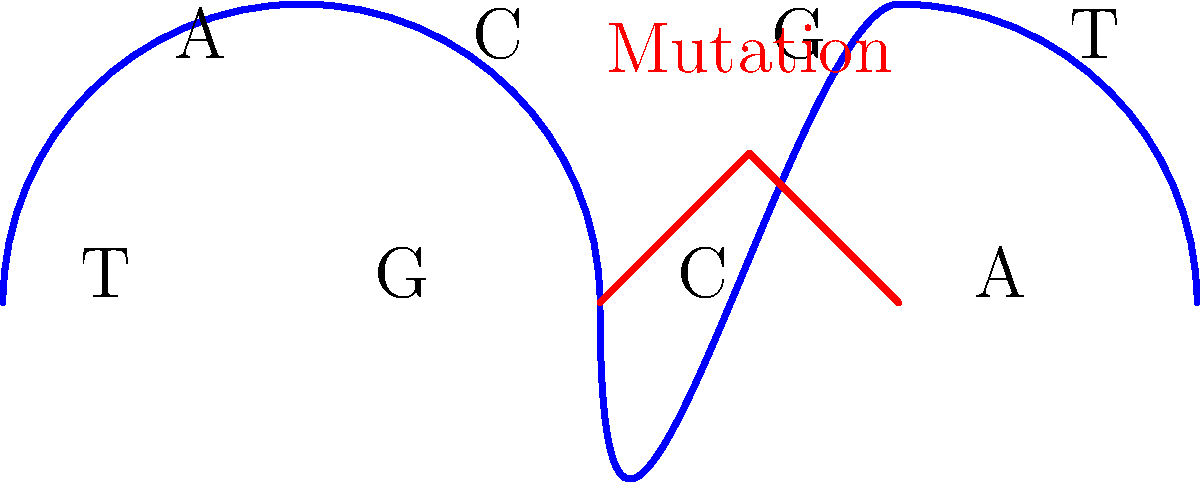In the DNA structure shown above, a genetic mutation has occurred. What type of mutation is represented by the red segment, and how might it affect the genetic information? To understand this mutation, let's break it down step-by-step:

1. DNA structure: The blue curve represents the double helix structure of DNA. Each rung of the "ladder" represents a base pair.

2. Base pairs: In DNA, adenine (A) always pairs with thymine (T), and cytosine (C) always pairs with guanine (G). This is called complementary base pairing.

3. Normal sequence: The normal sequence shown is A-T, C-G, G-C, T-A.

4. Mutation: The red segment represents a change in the DNA structure.

5. Type of mutation: This is a point mutation, specifically an insertion mutation. An extra base pair has been added to the DNA sequence.

6. Effects of the mutation:
   a) It shifts the reading frame of the genetic code.
   b) This can cause a frameshift mutation, where all subsequent codons are misread.
   c) It may result in a completely different amino acid sequence being produced.
   d) In severe cases, it can lead to a premature stop codon, truncating the protein.

7. Consequences: Depending on where this mutation occurs, it could:
   a) Have no effect (silent mutation)
   b) Alter protein function slightly
   c) Render the protein non-functional
   d) In rare cases, provide a beneficial change

The severity of the mutation's effect depends on its location in the gene and the specific protein being coded.
Answer: Insertion mutation; shifts reading frame, potentially altering protein sequence and function. 